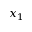<formula> <loc_0><loc_0><loc_500><loc_500>x _ { 1 }</formula> 